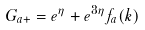<formula> <loc_0><loc_0><loc_500><loc_500>G _ { a + } = e ^ { \eta } + e ^ { 3 \eta } f _ { a } ( k )</formula> 